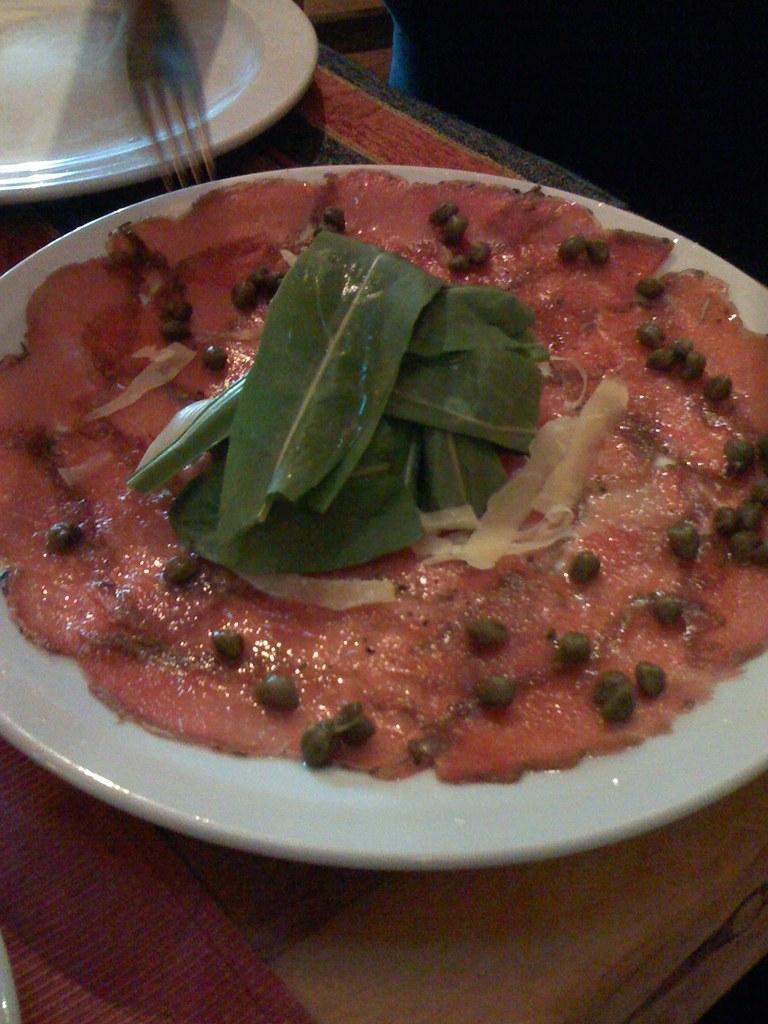Could you give a brief overview of what you see in this image? In the foreground of this picture, there is some food on a platter which is placed on the table. On the table, there is one more platter and table mats on it. There is also a fork on the top side of the image. 